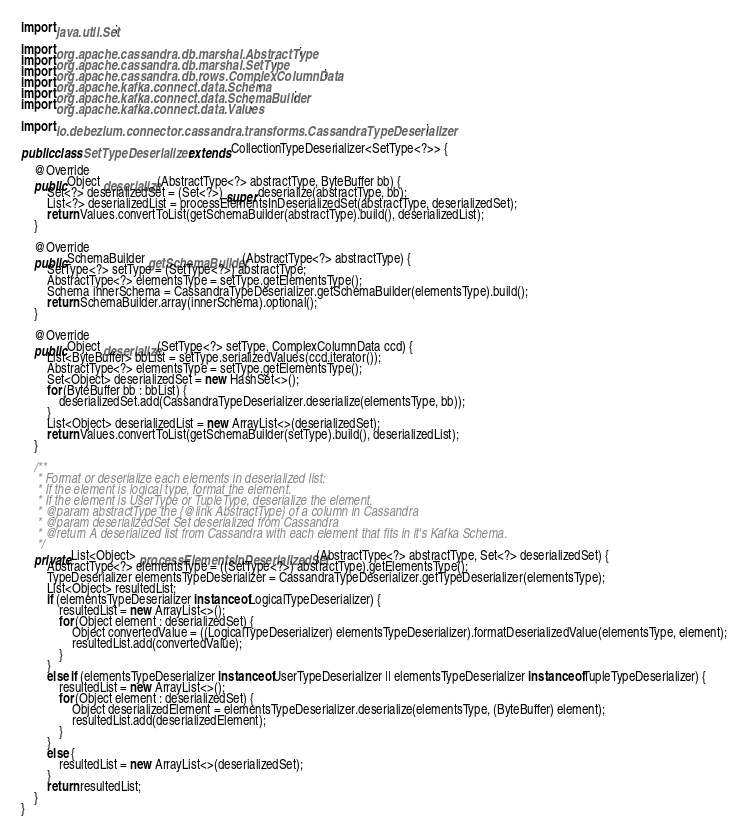<code> <loc_0><loc_0><loc_500><loc_500><_Java_>import java.util.Set;

import org.apache.cassandra.db.marshal.AbstractType;
import org.apache.cassandra.db.marshal.SetType;
import org.apache.cassandra.db.rows.ComplexColumnData;
import org.apache.kafka.connect.data.Schema;
import org.apache.kafka.connect.data.SchemaBuilder;
import org.apache.kafka.connect.data.Values;

import io.debezium.connector.cassandra.transforms.CassandraTypeDeserializer;

public class SetTypeDeserializer extends CollectionTypeDeserializer<SetType<?>> {

    @Override
    public Object deserialize(AbstractType<?> abstractType, ByteBuffer bb) {
        Set<?> deserializedSet = (Set<?>) super.deserialize(abstractType, bb);
        List<?> deserializedList = processElementsInDeserializedSet(abstractType, deserializedSet);
        return Values.convertToList(getSchemaBuilder(abstractType).build(), deserializedList);
    }

    @Override
    public SchemaBuilder getSchemaBuilder(AbstractType<?> abstractType) {
        SetType<?> setType = (SetType<?>) abstractType;
        AbstractType<?> elementsType = setType.getElementsType();
        Schema innerSchema = CassandraTypeDeserializer.getSchemaBuilder(elementsType).build();
        return SchemaBuilder.array(innerSchema).optional();
    }

    @Override
    public Object deserialize(SetType<?> setType, ComplexColumnData ccd) {
        List<ByteBuffer> bbList = setType.serializedValues(ccd.iterator());
        AbstractType<?> elementsType = setType.getElementsType();
        Set<Object> deserializedSet = new HashSet<>();
        for (ByteBuffer bb : bbList) {
            deserializedSet.add(CassandraTypeDeserializer.deserialize(elementsType, bb));
        }
        List<Object> deserializedList = new ArrayList<>(deserializedSet);
        return Values.convertToList(getSchemaBuilder(setType).build(), deserializedList);
    }

    /**
     * Format or deserialize each elements in deserialized list:
     * If the element is logical type, format the element.
     * If the element is UserType or TupleType, deserialize the element.
     * @param abstractType the {@link AbstractType} of a column in Cassandra
     * @param deserializedSet Set deserialized from Cassandra
     * @return A deserialized list from Cassandra with each element that fits in it's Kafka Schema.
     */
    private List<Object> processElementsInDeserializedSet(AbstractType<?> abstractType, Set<?> deserializedSet) {
        AbstractType<?> elementsType = ((SetType<?>) abstractType).getElementsType();
        TypeDeserializer elementsTypeDeserializer = CassandraTypeDeserializer.getTypeDeserializer(elementsType);
        List<Object> resultedList;
        if (elementsTypeDeserializer instanceof LogicalTypeDeserializer) {
            resultedList = new ArrayList<>();
            for (Object element : deserializedSet) {
                Object convertedValue = ((LogicalTypeDeserializer) elementsTypeDeserializer).formatDeserializedValue(elementsType, element);
                resultedList.add(convertedValue);
            }
        }
        else if (elementsTypeDeserializer instanceof UserTypeDeserializer || elementsTypeDeserializer instanceof TupleTypeDeserializer) {
            resultedList = new ArrayList<>();
            for (Object element : deserializedSet) {
                Object deserializedElement = elementsTypeDeserializer.deserialize(elementsType, (ByteBuffer) element);
                resultedList.add(deserializedElement);
            }
        }
        else {
            resultedList = new ArrayList<>(deserializedSet);
        }
        return resultedList;
    }
}
</code> 